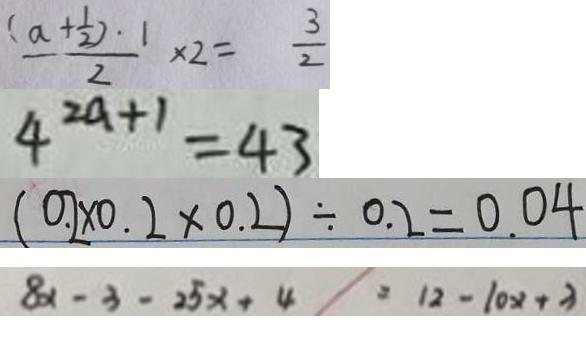<formula> <loc_0><loc_0><loc_500><loc_500>\frac { ( a + \frac { 1 } { 2 } ) \cdot 1 } { 2 } \times 2 = \frac { 3 } { 2 } 
 4 ^ { 2 a + 1 } = 4 3 
 ( 0 . 2 \times 0 . 2 \times 0 . 2 ) \div 0 . 2 = 0 . 0 4 
 8 x - 3 - 2 5 x + 4 = 1 2 - 1 0 x + 3</formula> 